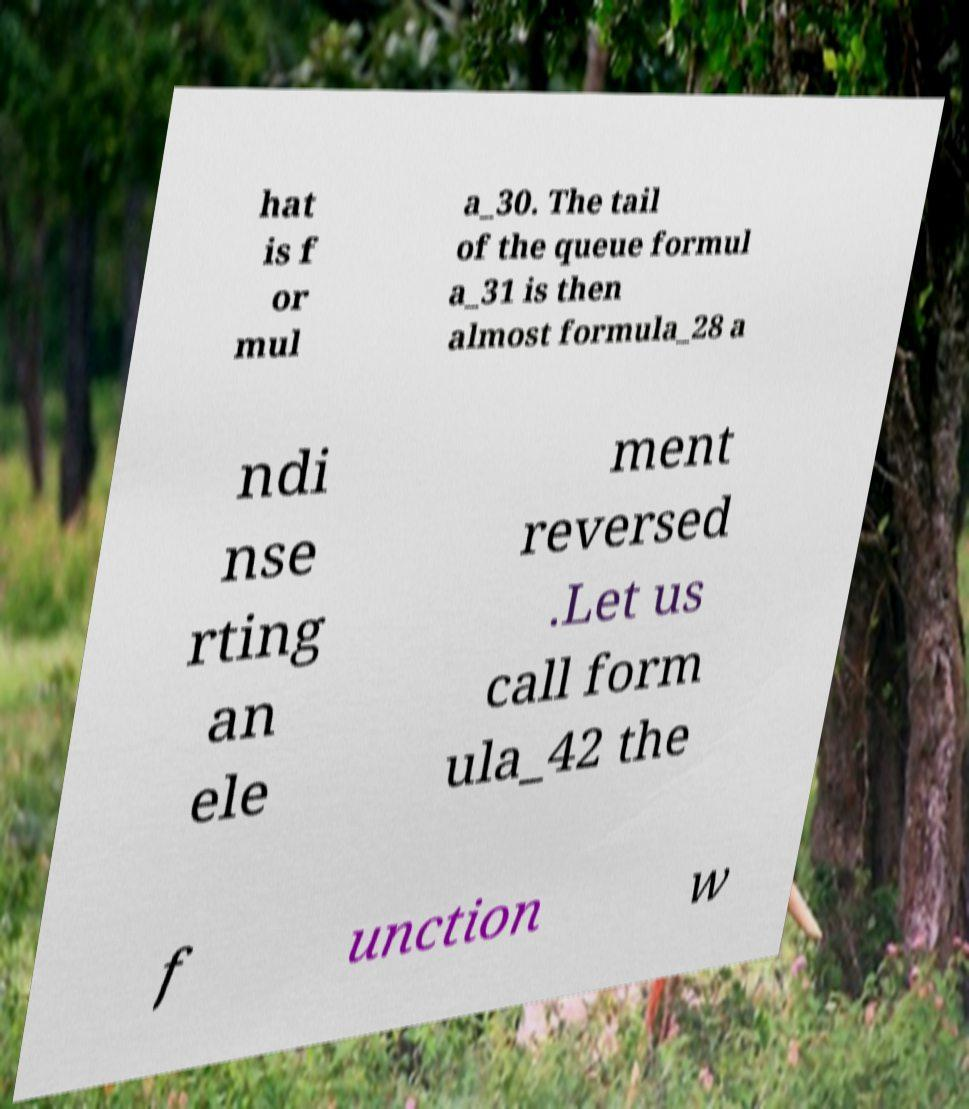Please read and relay the text visible in this image. What does it say? hat is f or mul a_30. The tail of the queue formul a_31 is then almost formula_28 a ndi nse rting an ele ment reversed .Let us call form ula_42 the f unction w 